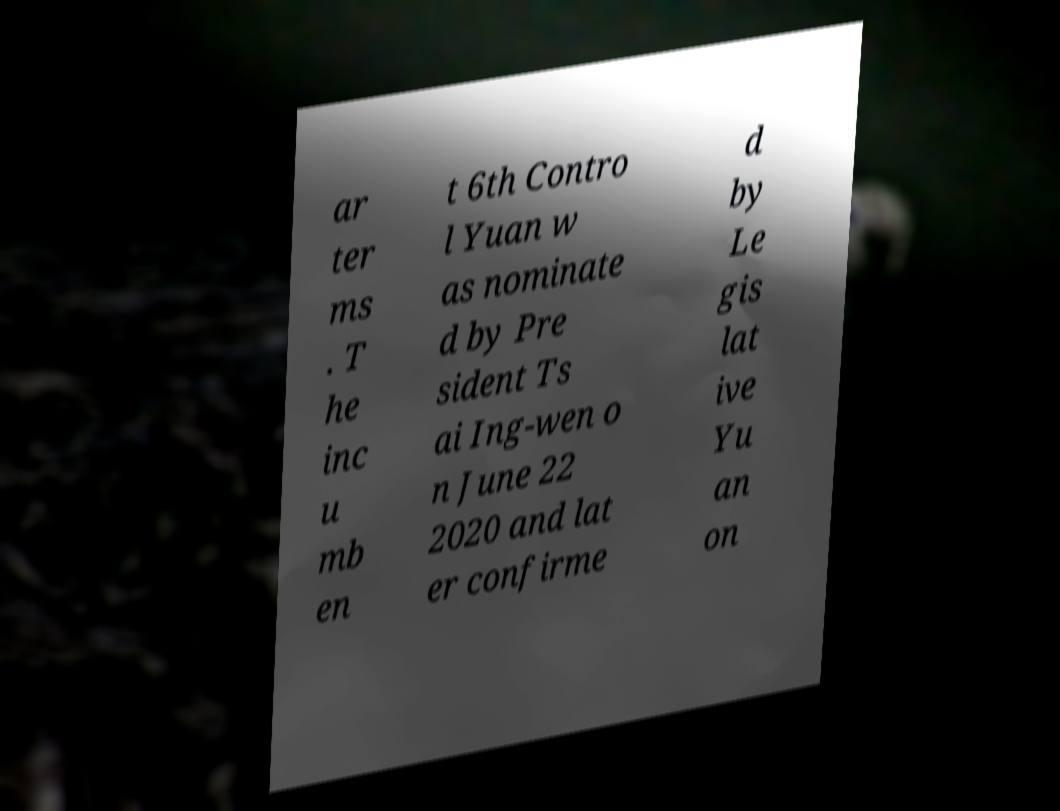Could you extract and type out the text from this image? ar ter ms . T he inc u mb en t 6th Contro l Yuan w as nominate d by Pre sident Ts ai Ing-wen o n June 22 2020 and lat er confirme d by Le gis lat ive Yu an on 